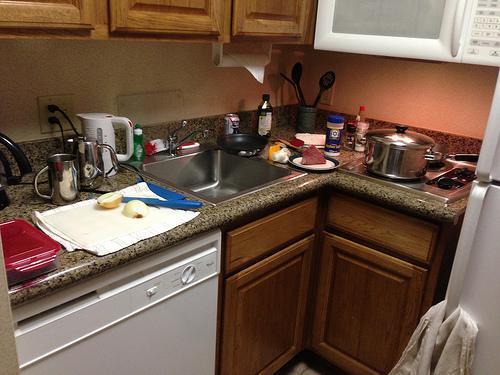How many people are shown?
Give a very brief answer. 0. How many pans are on the stove top?
Give a very brief answer. 2. 